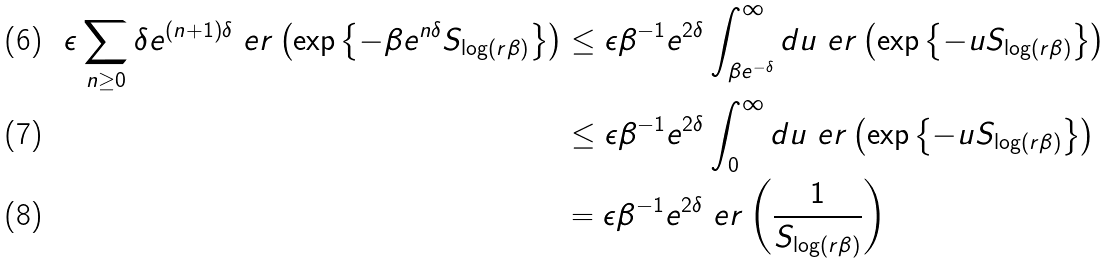<formula> <loc_0><loc_0><loc_500><loc_500>\epsilon \sum _ { n \geq 0 } \delta e ^ { ( n + 1 ) \delta } \ e r \left ( \exp \left \{ - \beta e ^ { n \delta } S _ { \log ( r \beta ) } \right \} \right ) & \leq \epsilon \beta ^ { - 1 } e ^ { 2 \delta } \int ^ { \infty } _ { \beta e ^ { - \delta } } d u \ e r \left ( \exp \left \{ - u S _ { \log ( r \beta ) } \right \} \right ) \\ & \leq \epsilon \beta ^ { - 1 } e ^ { 2 \delta } \int ^ { \infty } _ { 0 } d u \ e r \left ( \exp \left \{ - u S _ { \log ( r \beta ) } \right \} \right ) \\ & = \epsilon \beta ^ { - 1 } e ^ { 2 \delta } \ e r \left ( \frac { 1 } { S _ { \log ( r \beta ) } } \right )</formula> 